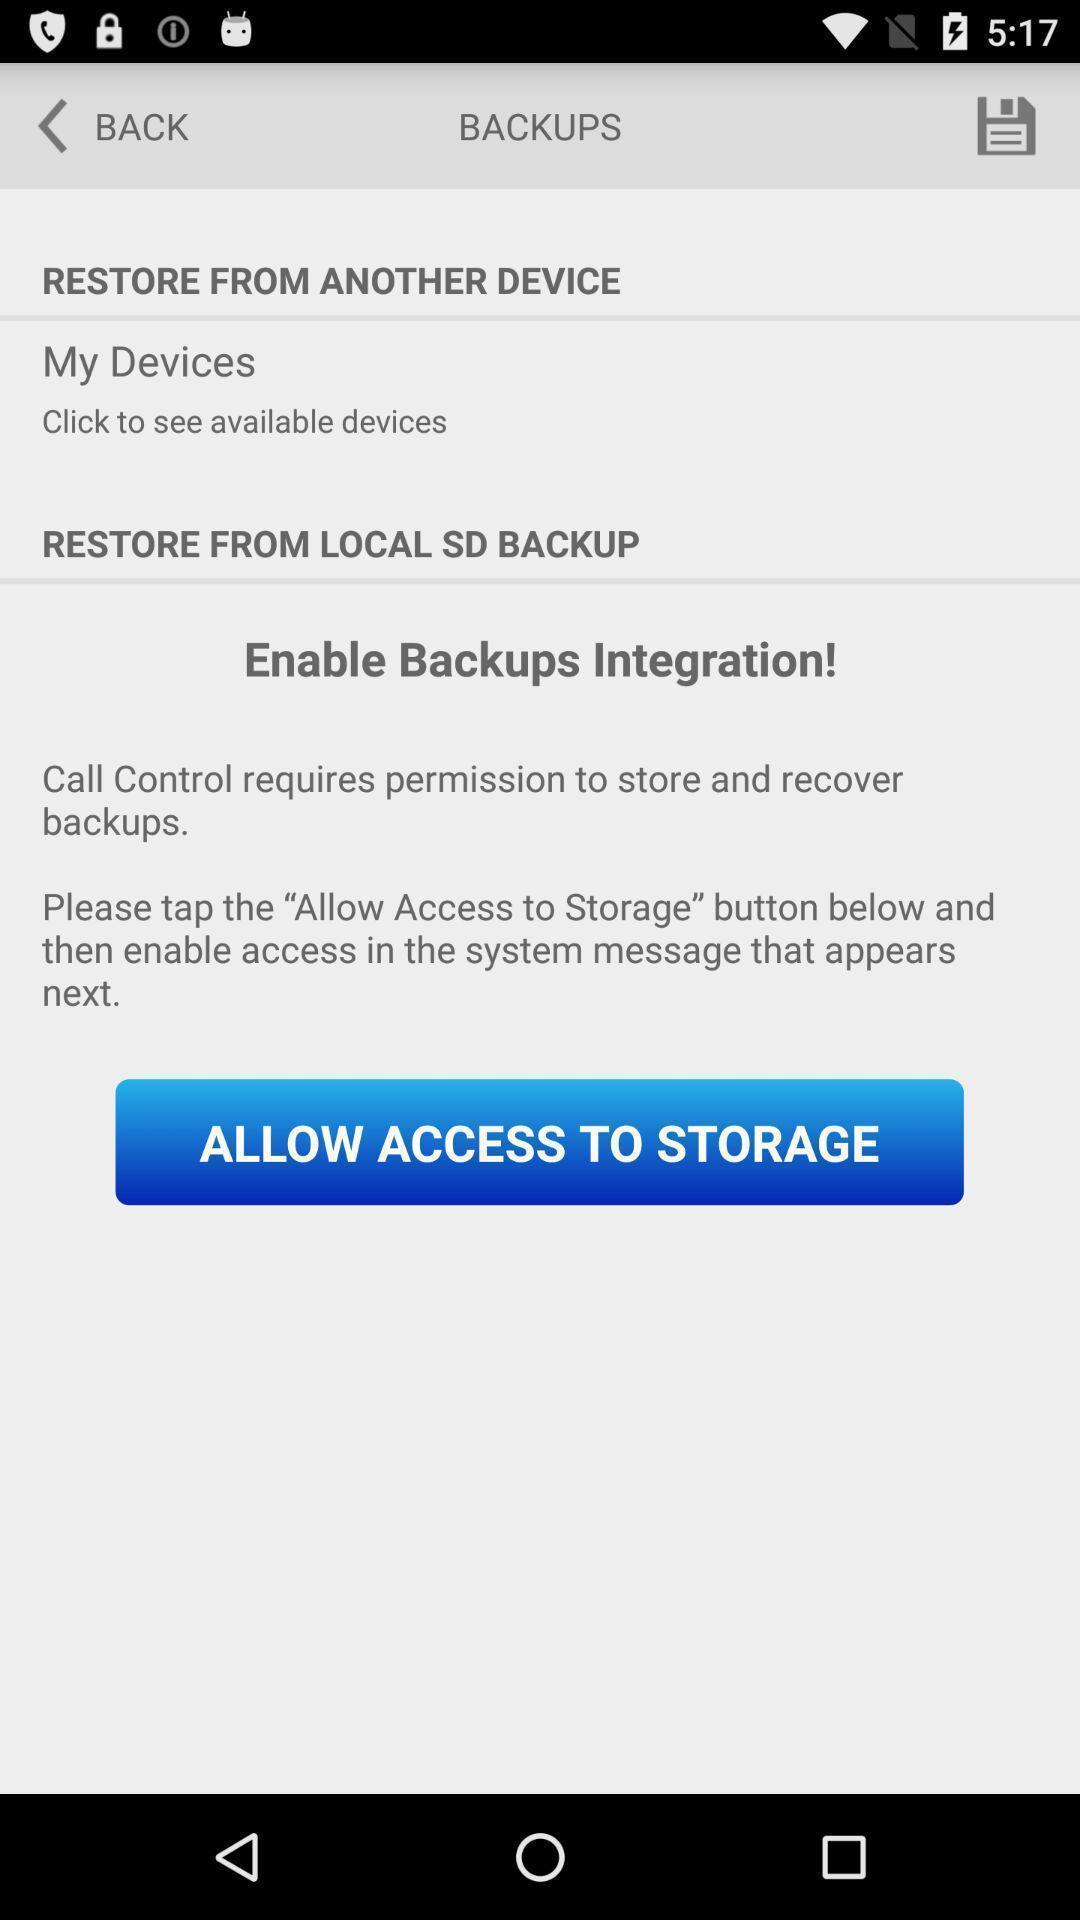Explain the elements present in this screenshot. Screen displaying access information about backup. 